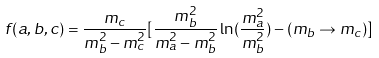Convert formula to latex. <formula><loc_0><loc_0><loc_500><loc_500>f ( a , b , c ) = \frac { m _ { c } } { m _ { b } ^ { 2 } - m _ { c } ^ { 2 } } [ \frac { m _ { b } ^ { 2 } } { m _ { a } ^ { 2 } - m _ { b } ^ { 2 } } \ln ( \frac { m _ { a } ^ { 2 } } { m _ { b } ^ { 2 } } ) - ( m _ { b } \rightarrow m _ { c } ) ]</formula> 